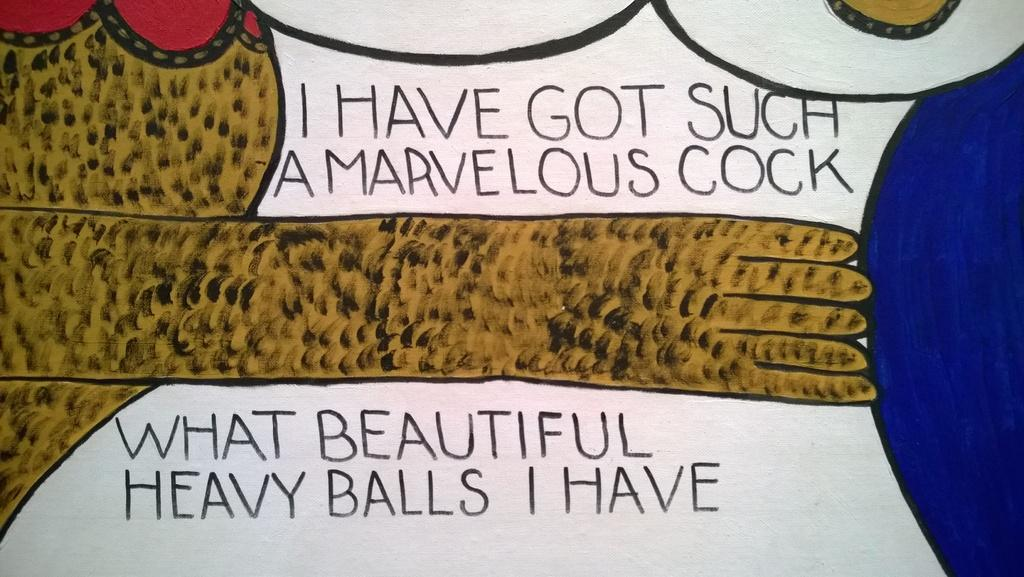What is the main subject of the image? There is a painting in the image. What is happening in the painting? The painting depicts a hand pushing a blue ball. Where can text be found in the image? There is text at the top and bottom of the image. Can you see any wings on the horse in the image? There is no horse or wings present in the image; it features a painting of a hand pushing a blue ball with text at the top and bottom. 